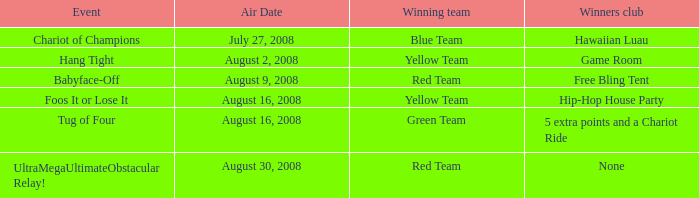Which club under winners has a hang tight event organized? Game Room. 